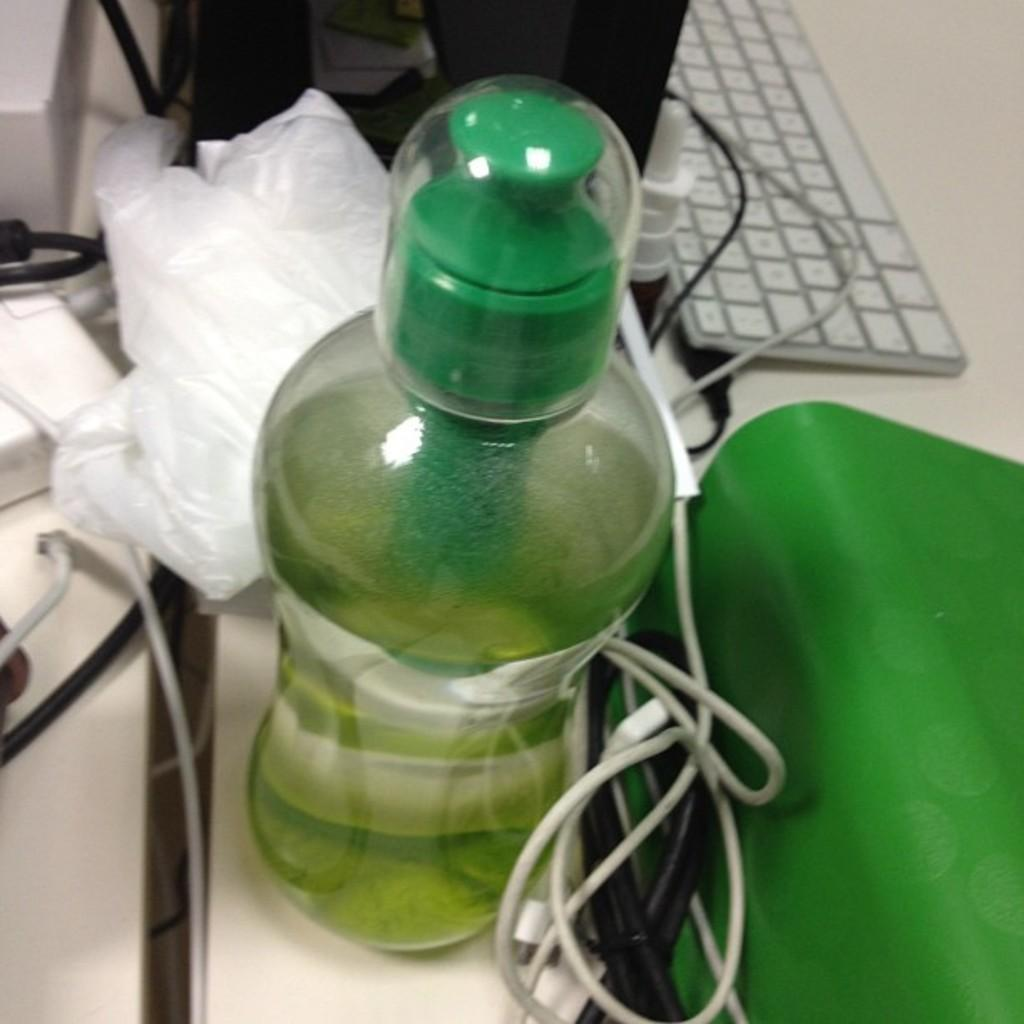What is on the table in the image? There is a bottle, a keyboard, and wires on the table. Are there any other objects on the table besides the mentioned items? Yes, there are other objects on the table. What type of device is the keyboard used for? The keyboard is likely used for typing or inputting data. What type of cemetery can be seen in the background of the image? There is no cemetery visible in the image; it only shows objects on a table. How many wings are present on the keyboard in the image? There are no wings on the keyboard in the image; it is a standard keyboard without any additional features. 